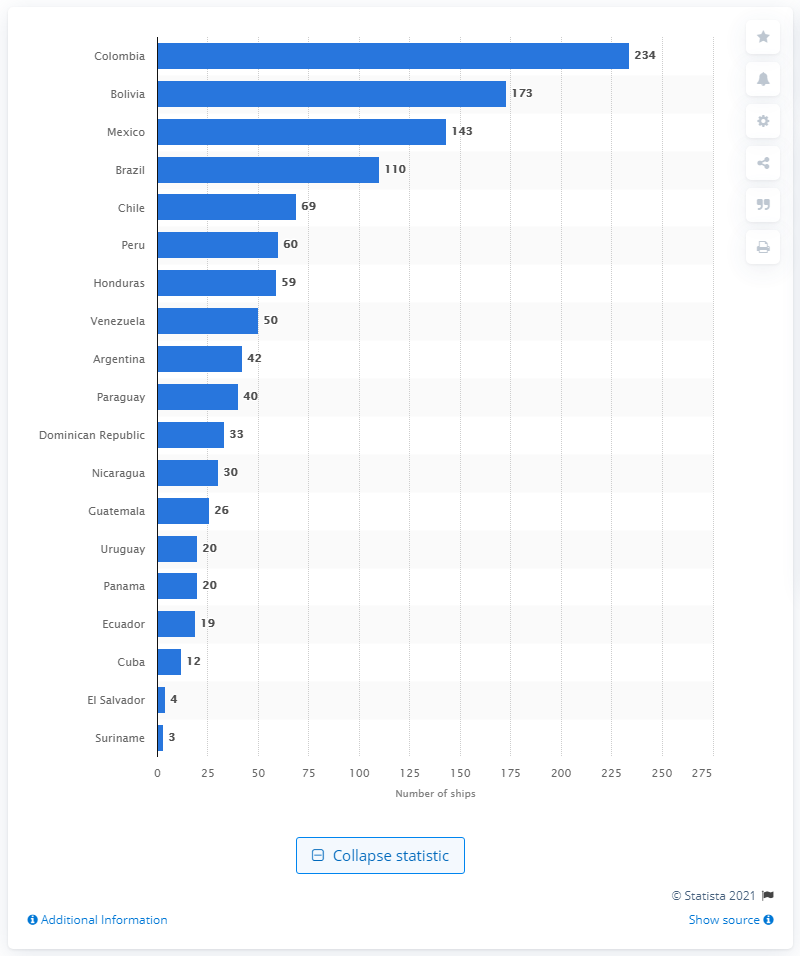List a handful of essential elements in this visual. Colombia had 234 ships at its disposal. Bolivia has the most powerful naval fleet among all Latin American countries. 